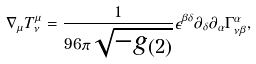<formula> <loc_0><loc_0><loc_500><loc_500>\nabla _ { \mu } T ^ { \mu } _ { \nu } = \frac { 1 } { 9 6 \pi \sqrt { - g _ { ( 2 ) } } } \epsilon ^ { \beta \delta } \partial _ { \delta } \partial _ { \alpha } \Gamma ^ { \alpha } _ { \nu \beta } ,</formula> 